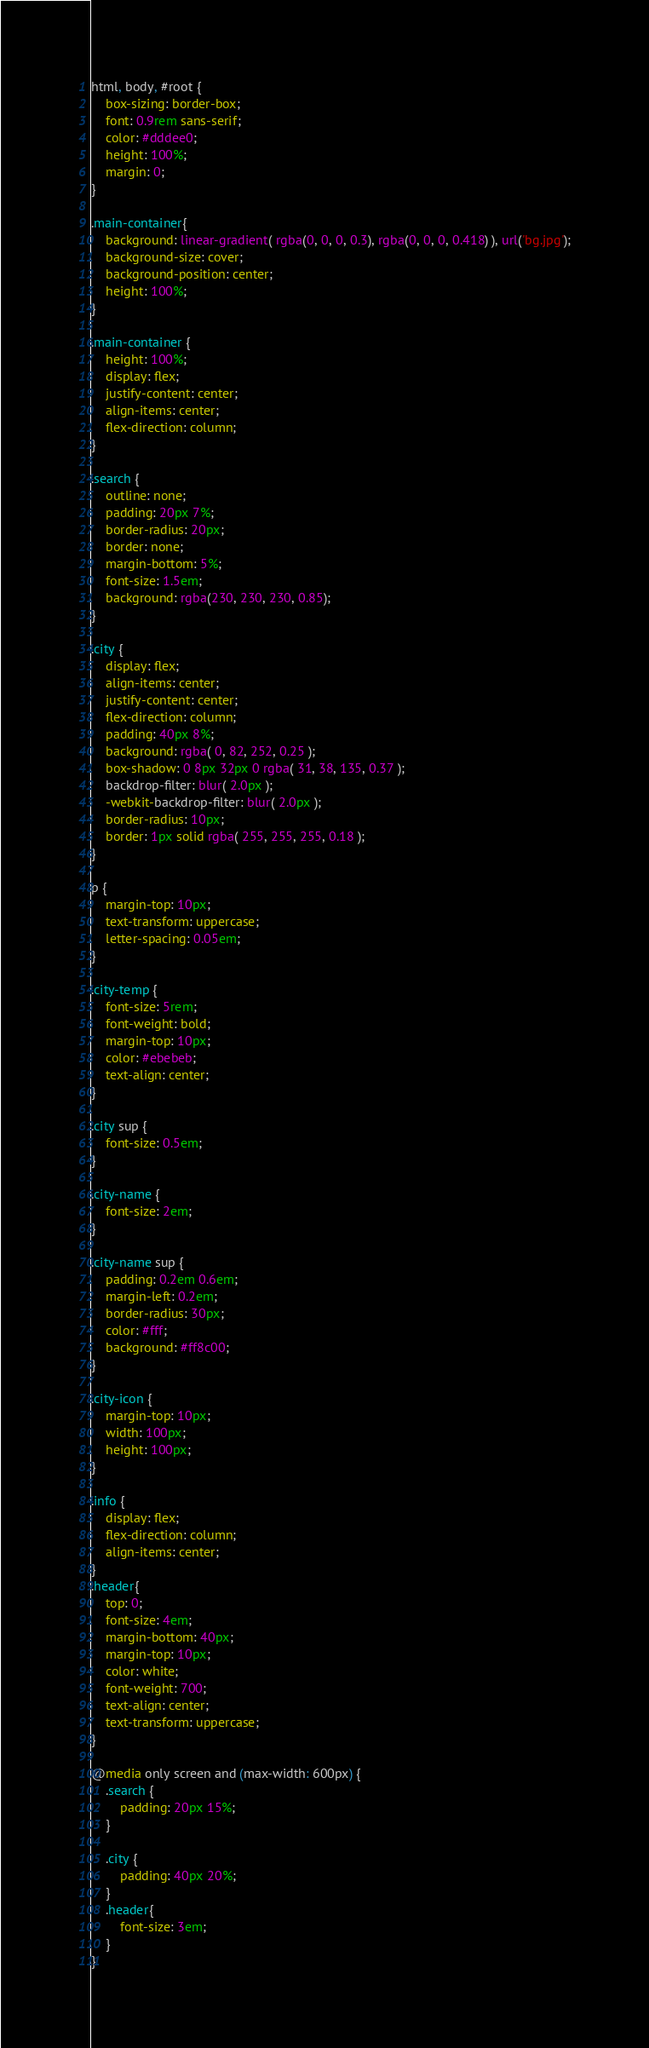Convert code to text. <code><loc_0><loc_0><loc_500><loc_500><_CSS_>html, body, #root {
    box-sizing: border-box;
    font: 0.9rem sans-serif;
    color: #dddee0;
    height: 100%;
    margin: 0;
}

.main-container{
    background: linear-gradient( rgba(0, 0, 0, 0.3), rgba(0, 0, 0, 0.418) ), url('bg.jpg');
    background-size: cover;
    background-position: center;
    height: 100%;
}

.main-container {
    height: 100%;
    display: flex;
    justify-content: center;
    align-items: center;
    flex-direction: column;
}

.search {
    outline: none;
    padding: 20px 7%;
    border-radius: 20px;
    border: none;
    margin-bottom: 5%;
    font-size: 1.5em;
    background: rgba(230, 230, 230, 0.85);
}

.city {
    display: flex;
    align-items: center;
    justify-content: center;
    flex-direction: column;
    padding: 40px 8%;
    background: rgba( 0, 82, 252, 0.25 );
    box-shadow: 0 8px 32px 0 rgba( 31, 38, 135, 0.37 );
    backdrop-filter: blur( 2.0px );
    -webkit-backdrop-filter: blur( 2.0px );
    border-radius: 10px;
    border: 1px solid rgba( 255, 255, 255, 0.18 );
}

p {
    margin-top: 10px;
    text-transform: uppercase;
    letter-spacing: 0.05em;
}

.city-temp {
    font-size: 5rem;
    font-weight: bold;
    margin-top: 10px;
    color: #ebebeb;
    text-align: center;
}

.city sup {
    font-size: 0.5em;
}

.city-name {
    font-size: 2em;
}

.city-name sup {
    padding: 0.2em 0.6em;
    margin-left: 0.2em;
    border-radius: 30px;
    color: #fff;
    background: #ff8c00;
}

.city-icon {
    margin-top: 10px;
    width: 100px;
    height: 100px;
}

.info {
    display: flex;
    flex-direction: column;
    align-items: center;
}
.header{
    top: 0;
    font-size: 4em;
    margin-bottom: 40px;
    margin-top: 10px;
    color: white;
    font-weight: 700;
    text-align: center;
    text-transform: uppercase;
}

@media only screen and (max-width: 600px) {
    .search {
        padding: 20px 15%;
    }

    .city {
        padding: 40px 20%;
    }
    .header{
        font-size: 3em;
    }
}</code> 